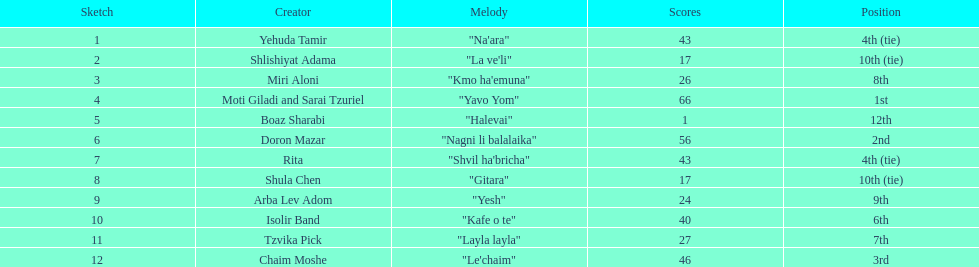How many points does the artist rita have? 43. 